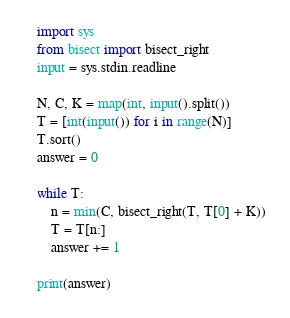Convert code to text. <code><loc_0><loc_0><loc_500><loc_500><_Python_>import sys
from bisect import bisect_right
input = sys.stdin.readline

N, C, K = map(int, input().split())
T = [int(input()) for i in range(N)]
T.sort()
answer = 0

while T:
    n = min(C, bisect_right(T, T[0] + K))
    T = T[n:]
    answer += 1

print(answer)</code> 